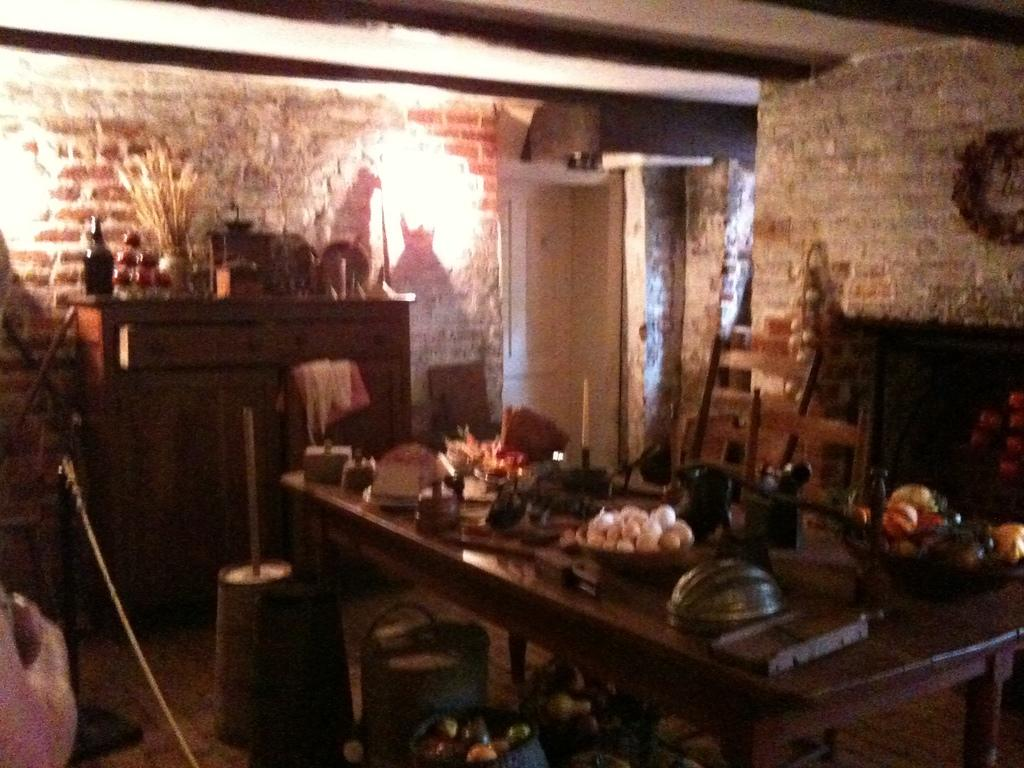What is the main object in the image? There is a table in the image. What can be found on the table? There are items on the table. Can you describe anything visible in the background? There is a bottle visible in the background. How would you describe the lighting in the image? The image appears to be slightly dark. Is there a beggar attending the meeting in the image? There is no meeting or beggar present in the image. What type of shade is covering the table in the image? There is no shade covering the table in the image; it is not mentioned in the provided facts. 